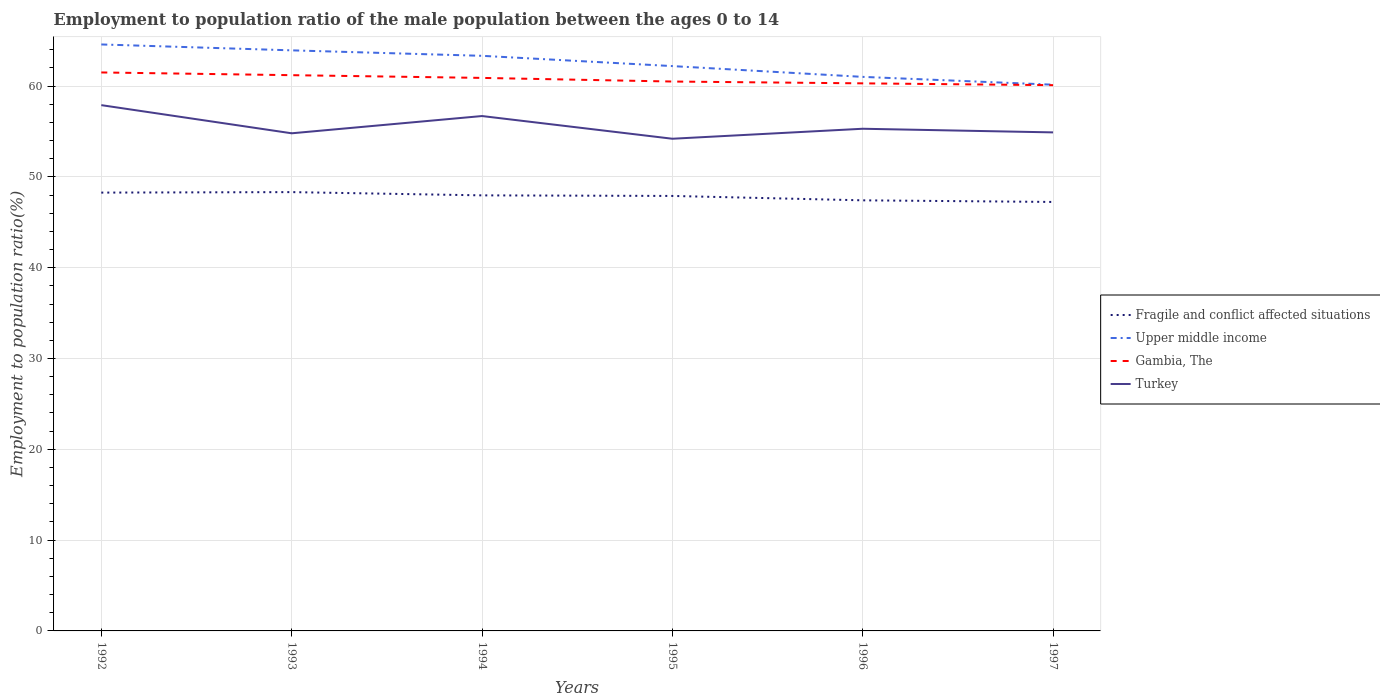How many different coloured lines are there?
Offer a terse response. 4. Does the line corresponding to Turkey intersect with the line corresponding to Fragile and conflict affected situations?
Your answer should be very brief. No. Is the number of lines equal to the number of legend labels?
Make the answer very short. Yes. Across all years, what is the maximum employment to population ratio in Fragile and conflict affected situations?
Offer a very short reply. 47.24. In which year was the employment to population ratio in Gambia, The maximum?
Provide a short and direct response. 1997. What is the total employment to population ratio in Fragile and conflict affected situations in the graph?
Provide a succinct answer. 0.48. What is the difference between the highest and the second highest employment to population ratio in Fragile and conflict affected situations?
Keep it short and to the point. 1.08. What is the difference between the highest and the lowest employment to population ratio in Gambia, The?
Your answer should be compact. 3. How many lines are there?
Your answer should be compact. 4. How many years are there in the graph?
Make the answer very short. 6. Are the values on the major ticks of Y-axis written in scientific E-notation?
Ensure brevity in your answer.  No. Does the graph contain any zero values?
Keep it short and to the point. No. How many legend labels are there?
Provide a short and direct response. 4. What is the title of the graph?
Keep it short and to the point. Employment to population ratio of the male population between the ages 0 to 14. What is the Employment to population ratio(%) in Fragile and conflict affected situations in 1992?
Give a very brief answer. 48.27. What is the Employment to population ratio(%) of Upper middle income in 1992?
Give a very brief answer. 64.58. What is the Employment to population ratio(%) of Gambia, The in 1992?
Provide a succinct answer. 61.5. What is the Employment to population ratio(%) in Turkey in 1992?
Give a very brief answer. 57.9. What is the Employment to population ratio(%) of Fragile and conflict affected situations in 1993?
Give a very brief answer. 48.32. What is the Employment to population ratio(%) in Upper middle income in 1993?
Your response must be concise. 63.93. What is the Employment to population ratio(%) of Gambia, The in 1993?
Provide a succinct answer. 61.2. What is the Employment to population ratio(%) of Turkey in 1993?
Your response must be concise. 54.8. What is the Employment to population ratio(%) in Fragile and conflict affected situations in 1994?
Offer a very short reply. 47.96. What is the Employment to population ratio(%) of Upper middle income in 1994?
Offer a terse response. 63.33. What is the Employment to population ratio(%) of Gambia, The in 1994?
Your answer should be very brief. 60.9. What is the Employment to population ratio(%) in Turkey in 1994?
Make the answer very short. 56.7. What is the Employment to population ratio(%) of Fragile and conflict affected situations in 1995?
Provide a short and direct response. 47.9. What is the Employment to population ratio(%) in Upper middle income in 1995?
Make the answer very short. 62.2. What is the Employment to population ratio(%) in Gambia, The in 1995?
Provide a succinct answer. 60.5. What is the Employment to population ratio(%) in Turkey in 1995?
Make the answer very short. 54.2. What is the Employment to population ratio(%) in Fragile and conflict affected situations in 1996?
Your answer should be very brief. 47.42. What is the Employment to population ratio(%) in Upper middle income in 1996?
Provide a succinct answer. 61.01. What is the Employment to population ratio(%) of Gambia, The in 1996?
Offer a terse response. 60.3. What is the Employment to population ratio(%) of Turkey in 1996?
Offer a terse response. 55.3. What is the Employment to population ratio(%) of Fragile and conflict affected situations in 1997?
Your answer should be compact. 47.24. What is the Employment to population ratio(%) in Upper middle income in 1997?
Your response must be concise. 60.15. What is the Employment to population ratio(%) in Gambia, The in 1997?
Provide a short and direct response. 60.1. What is the Employment to population ratio(%) in Turkey in 1997?
Provide a succinct answer. 54.9. Across all years, what is the maximum Employment to population ratio(%) in Fragile and conflict affected situations?
Keep it short and to the point. 48.32. Across all years, what is the maximum Employment to population ratio(%) in Upper middle income?
Offer a very short reply. 64.58. Across all years, what is the maximum Employment to population ratio(%) of Gambia, The?
Provide a short and direct response. 61.5. Across all years, what is the maximum Employment to population ratio(%) in Turkey?
Offer a terse response. 57.9. Across all years, what is the minimum Employment to population ratio(%) in Fragile and conflict affected situations?
Make the answer very short. 47.24. Across all years, what is the minimum Employment to population ratio(%) of Upper middle income?
Provide a short and direct response. 60.15. Across all years, what is the minimum Employment to population ratio(%) in Gambia, The?
Make the answer very short. 60.1. Across all years, what is the minimum Employment to population ratio(%) of Turkey?
Provide a succinct answer. 54.2. What is the total Employment to population ratio(%) of Fragile and conflict affected situations in the graph?
Make the answer very short. 287.12. What is the total Employment to population ratio(%) of Upper middle income in the graph?
Provide a succinct answer. 375.22. What is the total Employment to population ratio(%) of Gambia, The in the graph?
Keep it short and to the point. 364.5. What is the total Employment to population ratio(%) in Turkey in the graph?
Provide a short and direct response. 333.8. What is the difference between the Employment to population ratio(%) of Fragile and conflict affected situations in 1992 and that in 1993?
Provide a short and direct response. -0.05. What is the difference between the Employment to population ratio(%) in Upper middle income in 1992 and that in 1993?
Ensure brevity in your answer.  0.65. What is the difference between the Employment to population ratio(%) of Fragile and conflict affected situations in 1992 and that in 1994?
Your answer should be compact. 0.3. What is the difference between the Employment to population ratio(%) of Upper middle income in 1992 and that in 1994?
Your answer should be compact. 1.25. What is the difference between the Employment to population ratio(%) of Fragile and conflict affected situations in 1992 and that in 1995?
Your answer should be very brief. 0.37. What is the difference between the Employment to population ratio(%) of Upper middle income in 1992 and that in 1995?
Offer a terse response. 2.38. What is the difference between the Employment to population ratio(%) in Gambia, The in 1992 and that in 1995?
Make the answer very short. 1. What is the difference between the Employment to population ratio(%) of Fragile and conflict affected situations in 1992 and that in 1996?
Your answer should be very brief. 0.85. What is the difference between the Employment to population ratio(%) in Upper middle income in 1992 and that in 1996?
Your answer should be very brief. 3.57. What is the difference between the Employment to population ratio(%) in Gambia, The in 1992 and that in 1996?
Ensure brevity in your answer.  1.2. What is the difference between the Employment to population ratio(%) of Fragile and conflict affected situations in 1992 and that in 1997?
Ensure brevity in your answer.  1.03. What is the difference between the Employment to population ratio(%) in Upper middle income in 1992 and that in 1997?
Provide a succinct answer. 4.43. What is the difference between the Employment to population ratio(%) in Fragile and conflict affected situations in 1993 and that in 1994?
Keep it short and to the point. 0.36. What is the difference between the Employment to population ratio(%) in Upper middle income in 1993 and that in 1994?
Ensure brevity in your answer.  0.6. What is the difference between the Employment to population ratio(%) of Fragile and conflict affected situations in 1993 and that in 1995?
Keep it short and to the point. 0.42. What is the difference between the Employment to population ratio(%) of Upper middle income in 1993 and that in 1995?
Ensure brevity in your answer.  1.73. What is the difference between the Employment to population ratio(%) in Gambia, The in 1993 and that in 1995?
Provide a succinct answer. 0.7. What is the difference between the Employment to population ratio(%) in Fragile and conflict affected situations in 1993 and that in 1996?
Offer a terse response. 0.9. What is the difference between the Employment to population ratio(%) of Upper middle income in 1993 and that in 1996?
Offer a very short reply. 2.92. What is the difference between the Employment to population ratio(%) in Gambia, The in 1993 and that in 1996?
Provide a short and direct response. 0.9. What is the difference between the Employment to population ratio(%) of Fragile and conflict affected situations in 1993 and that in 1997?
Keep it short and to the point. 1.08. What is the difference between the Employment to population ratio(%) of Upper middle income in 1993 and that in 1997?
Offer a terse response. 3.78. What is the difference between the Employment to population ratio(%) of Gambia, The in 1993 and that in 1997?
Your answer should be compact. 1.1. What is the difference between the Employment to population ratio(%) of Fragile and conflict affected situations in 1994 and that in 1995?
Give a very brief answer. 0.06. What is the difference between the Employment to population ratio(%) of Upper middle income in 1994 and that in 1995?
Your answer should be very brief. 1.13. What is the difference between the Employment to population ratio(%) in Turkey in 1994 and that in 1995?
Offer a very short reply. 2.5. What is the difference between the Employment to population ratio(%) of Fragile and conflict affected situations in 1994 and that in 1996?
Your answer should be very brief. 0.55. What is the difference between the Employment to population ratio(%) of Upper middle income in 1994 and that in 1996?
Your answer should be very brief. 2.32. What is the difference between the Employment to population ratio(%) in Gambia, The in 1994 and that in 1996?
Make the answer very short. 0.6. What is the difference between the Employment to population ratio(%) in Turkey in 1994 and that in 1996?
Your answer should be very brief. 1.4. What is the difference between the Employment to population ratio(%) of Fragile and conflict affected situations in 1994 and that in 1997?
Your answer should be compact. 0.73. What is the difference between the Employment to population ratio(%) in Upper middle income in 1994 and that in 1997?
Make the answer very short. 3.18. What is the difference between the Employment to population ratio(%) of Gambia, The in 1994 and that in 1997?
Provide a succinct answer. 0.8. What is the difference between the Employment to population ratio(%) in Fragile and conflict affected situations in 1995 and that in 1996?
Provide a short and direct response. 0.48. What is the difference between the Employment to population ratio(%) of Upper middle income in 1995 and that in 1996?
Provide a succinct answer. 1.19. What is the difference between the Employment to population ratio(%) of Gambia, The in 1995 and that in 1996?
Offer a terse response. 0.2. What is the difference between the Employment to population ratio(%) in Fragile and conflict affected situations in 1995 and that in 1997?
Your answer should be very brief. 0.66. What is the difference between the Employment to population ratio(%) in Upper middle income in 1995 and that in 1997?
Keep it short and to the point. 2.05. What is the difference between the Employment to population ratio(%) in Gambia, The in 1995 and that in 1997?
Your answer should be compact. 0.4. What is the difference between the Employment to population ratio(%) in Fragile and conflict affected situations in 1996 and that in 1997?
Your answer should be very brief. 0.18. What is the difference between the Employment to population ratio(%) in Upper middle income in 1996 and that in 1997?
Provide a short and direct response. 0.86. What is the difference between the Employment to population ratio(%) in Gambia, The in 1996 and that in 1997?
Ensure brevity in your answer.  0.2. What is the difference between the Employment to population ratio(%) of Turkey in 1996 and that in 1997?
Make the answer very short. 0.4. What is the difference between the Employment to population ratio(%) of Fragile and conflict affected situations in 1992 and the Employment to population ratio(%) of Upper middle income in 1993?
Ensure brevity in your answer.  -15.66. What is the difference between the Employment to population ratio(%) in Fragile and conflict affected situations in 1992 and the Employment to population ratio(%) in Gambia, The in 1993?
Your answer should be very brief. -12.93. What is the difference between the Employment to population ratio(%) in Fragile and conflict affected situations in 1992 and the Employment to population ratio(%) in Turkey in 1993?
Provide a short and direct response. -6.53. What is the difference between the Employment to population ratio(%) of Upper middle income in 1992 and the Employment to population ratio(%) of Gambia, The in 1993?
Keep it short and to the point. 3.38. What is the difference between the Employment to population ratio(%) in Upper middle income in 1992 and the Employment to population ratio(%) in Turkey in 1993?
Provide a short and direct response. 9.78. What is the difference between the Employment to population ratio(%) in Fragile and conflict affected situations in 1992 and the Employment to population ratio(%) in Upper middle income in 1994?
Offer a very short reply. -15.06. What is the difference between the Employment to population ratio(%) of Fragile and conflict affected situations in 1992 and the Employment to population ratio(%) of Gambia, The in 1994?
Ensure brevity in your answer.  -12.63. What is the difference between the Employment to population ratio(%) in Fragile and conflict affected situations in 1992 and the Employment to population ratio(%) in Turkey in 1994?
Ensure brevity in your answer.  -8.43. What is the difference between the Employment to population ratio(%) in Upper middle income in 1992 and the Employment to population ratio(%) in Gambia, The in 1994?
Offer a terse response. 3.68. What is the difference between the Employment to population ratio(%) of Upper middle income in 1992 and the Employment to population ratio(%) of Turkey in 1994?
Make the answer very short. 7.88. What is the difference between the Employment to population ratio(%) of Gambia, The in 1992 and the Employment to population ratio(%) of Turkey in 1994?
Your answer should be very brief. 4.8. What is the difference between the Employment to population ratio(%) of Fragile and conflict affected situations in 1992 and the Employment to population ratio(%) of Upper middle income in 1995?
Ensure brevity in your answer.  -13.93. What is the difference between the Employment to population ratio(%) in Fragile and conflict affected situations in 1992 and the Employment to population ratio(%) in Gambia, The in 1995?
Your response must be concise. -12.23. What is the difference between the Employment to population ratio(%) in Fragile and conflict affected situations in 1992 and the Employment to population ratio(%) in Turkey in 1995?
Ensure brevity in your answer.  -5.93. What is the difference between the Employment to population ratio(%) of Upper middle income in 1992 and the Employment to population ratio(%) of Gambia, The in 1995?
Offer a very short reply. 4.08. What is the difference between the Employment to population ratio(%) of Upper middle income in 1992 and the Employment to population ratio(%) of Turkey in 1995?
Offer a terse response. 10.38. What is the difference between the Employment to population ratio(%) of Gambia, The in 1992 and the Employment to population ratio(%) of Turkey in 1995?
Provide a short and direct response. 7.3. What is the difference between the Employment to population ratio(%) of Fragile and conflict affected situations in 1992 and the Employment to population ratio(%) of Upper middle income in 1996?
Keep it short and to the point. -12.74. What is the difference between the Employment to population ratio(%) in Fragile and conflict affected situations in 1992 and the Employment to population ratio(%) in Gambia, The in 1996?
Offer a terse response. -12.03. What is the difference between the Employment to population ratio(%) of Fragile and conflict affected situations in 1992 and the Employment to population ratio(%) of Turkey in 1996?
Give a very brief answer. -7.03. What is the difference between the Employment to population ratio(%) in Upper middle income in 1992 and the Employment to population ratio(%) in Gambia, The in 1996?
Give a very brief answer. 4.28. What is the difference between the Employment to population ratio(%) in Upper middle income in 1992 and the Employment to population ratio(%) in Turkey in 1996?
Make the answer very short. 9.28. What is the difference between the Employment to population ratio(%) in Gambia, The in 1992 and the Employment to population ratio(%) in Turkey in 1996?
Offer a terse response. 6.2. What is the difference between the Employment to population ratio(%) in Fragile and conflict affected situations in 1992 and the Employment to population ratio(%) in Upper middle income in 1997?
Offer a very short reply. -11.88. What is the difference between the Employment to population ratio(%) of Fragile and conflict affected situations in 1992 and the Employment to population ratio(%) of Gambia, The in 1997?
Make the answer very short. -11.83. What is the difference between the Employment to population ratio(%) in Fragile and conflict affected situations in 1992 and the Employment to population ratio(%) in Turkey in 1997?
Give a very brief answer. -6.63. What is the difference between the Employment to population ratio(%) in Upper middle income in 1992 and the Employment to population ratio(%) in Gambia, The in 1997?
Give a very brief answer. 4.48. What is the difference between the Employment to population ratio(%) of Upper middle income in 1992 and the Employment to population ratio(%) of Turkey in 1997?
Provide a succinct answer. 9.68. What is the difference between the Employment to population ratio(%) in Gambia, The in 1992 and the Employment to population ratio(%) in Turkey in 1997?
Offer a very short reply. 6.6. What is the difference between the Employment to population ratio(%) of Fragile and conflict affected situations in 1993 and the Employment to population ratio(%) of Upper middle income in 1994?
Keep it short and to the point. -15.01. What is the difference between the Employment to population ratio(%) of Fragile and conflict affected situations in 1993 and the Employment to population ratio(%) of Gambia, The in 1994?
Your answer should be compact. -12.58. What is the difference between the Employment to population ratio(%) of Fragile and conflict affected situations in 1993 and the Employment to population ratio(%) of Turkey in 1994?
Offer a terse response. -8.38. What is the difference between the Employment to population ratio(%) in Upper middle income in 1993 and the Employment to population ratio(%) in Gambia, The in 1994?
Offer a very short reply. 3.03. What is the difference between the Employment to population ratio(%) of Upper middle income in 1993 and the Employment to population ratio(%) of Turkey in 1994?
Offer a terse response. 7.23. What is the difference between the Employment to population ratio(%) in Fragile and conflict affected situations in 1993 and the Employment to population ratio(%) in Upper middle income in 1995?
Provide a succinct answer. -13.88. What is the difference between the Employment to population ratio(%) in Fragile and conflict affected situations in 1993 and the Employment to population ratio(%) in Gambia, The in 1995?
Your answer should be compact. -12.18. What is the difference between the Employment to population ratio(%) of Fragile and conflict affected situations in 1993 and the Employment to population ratio(%) of Turkey in 1995?
Provide a short and direct response. -5.88. What is the difference between the Employment to population ratio(%) of Upper middle income in 1993 and the Employment to population ratio(%) of Gambia, The in 1995?
Ensure brevity in your answer.  3.43. What is the difference between the Employment to population ratio(%) of Upper middle income in 1993 and the Employment to population ratio(%) of Turkey in 1995?
Keep it short and to the point. 9.73. What is the difference between the Employment to population ratio(%) of Gambia, The in 1993 and the Employment to population ratio(%) of Turkey in 1995?
Make the answer very short. 7. What is the difference between the Employment to population ratio(%) of Fragile and conflict affected situations in 1993 and the Employment to population ratio(%) of Upper middle income in 1996?
Your response must be concise. -12.69. What is the difference between the Employment to population ratio(%) of Fragile and conflict affected situations in 1993 and the Employment to population ratio(%) of Gambia, The in 1996?
Ensure brevity in your answer.  -11.98. What is the difference between the Employment to population ratio(%) of Fragile and conflict affected situations in 1993 and the Employment to population ratio(%) of Turkey in 1996?
Make the answer very short. -6.98. What is the difference between the Employment to population ratio(%) of Upper middle income in 1993 and the Employment to population ratio(%) of Gambia, The in 1996?
Make the answer very short. 3.63. What is the difference between the Employment to population ratio(%) in Upper middle income in 1993 and the Employment to population ratio(%) in Turkey in 1996?
Your answer should be very brief. 8.63. What is the difference between the Employment to population ratio(%) of Fragile and conflict affected situations in 1993 and the Employment to population ratio(%) of Upper middle income in 1997?
Make the answer very short. -11.83. What is the difference between the Employment to population ratio(%) of Fragile and conflict affected situations in 1993 and the Employment to population ratio(%) of Gambia, The in 1997?
Make the answer very short. -11.78. What is the difference between the Employment to population ratio(%) in Fragile and conflict affected situations in 1993 and the Employment to population ratio(%) in Turkey in 1997?
Keep it short and to the point. -6.58. What is the difference between the Employment to population ratio(%) in Upper middle income in 1993 and the Employment to population ratio(%) in Gambia, The in 1997?
Keep it short and to the point. 3.83. What is the difference between the Employment to population ratio(%) in Upper middle income in 1993 and the Employment to population ratio(%) in Turkey in 1997?
Make the answer very short. 9.03. What is the difference between the Employment to population ratio(%) of Fragile and conflict affected situations in 1994 and the Employment to population ratio(%) of Upper middle income in 1995?
Offer a terse response. -14.24. What is the difference between the Employment to population ratio(%) in Fragile and conflict affected situations in 1994 and the Employment to population ratio(%) in Gambia, The in 1995?
Keep it short and to the point. -12.54. What is the difference between the Employment to population ratio(%) of Fragile and conflict affected situations in 1994 and the Employment to population ratio(%) of Turkey in 1995?
Make the answer very short. -6.24. What is the difference between the Employment to population ratio(%) in Upper middle income in 1994 and the Employment to population ratio(%) in Gambia, The in 1995?
Your answer should be compact. 2.83. What is the difference between the Employment to population ratio(%) of Upper middle income in 1994 and the Employment to population ratio(%) of Turkey in 1995?
Your response must be concise. 9.13. What is the difference between the Employment to population ratio(%) of Gambia, The in 1994 and the Employment to population ratio(%) of Turkey in 1995?
Give a very brief answer. 6.7. What is the difference between the Employment to population ratio(%) of Fragile and conflict affected situations in 1994 and the Employment to population ratio(%) of Upper middle income in 1996?
Ensure brevity in your answer.  -13.05. What is the difference between the Employment to population ratio(%) in Fragile and conflict affected situations in 1994 and the Employment to population ratio(%) in Gambia, The in 1996?
Offer a very short reply. -12.34. What is the difference between the Employment to population ratio(%) of Fragile and conflict affected situations in 1994 and the Employment to population ratio(%) of Turkey in 1996?
Provide a short and direct response. -7.33. What is the difference between the Employment to population ratio(%) in Upper middle income in 1994 and the Employment to population ratio(%) in Gambia, The in 1996?
Provide a succinct answer. 3.03. What is the difference between the Employment to population ratio(%) in Upper middle income in 1994 and the Employment to population ratio(%) in Turkey in 1996?
Offer a terse response. 8.03. What is the difference between the Employment to population ratio(%) in Fragile and conflict affected situations in 1994 and the Employment to population ratio(%) in Upper middle income in 1997?
Keep it short and to the point. -12.19. What is the difference between the Employment to population ratio(%) of Fragile and conflict affected situations in 1994 and the Employment to population ratio(%) of Gambia, The in 1997?
Provide a succinct answer. -12.13. What is the difference between the Employment to population ratio(%) in Fragile and conflict affected situations in 1994 and the Employment to population ratio(%) in Turkey in 1997?
Your response must be concise. -6.94. What is the difference between the Employment to population ratio(%) of Upper middle income in 1994 and the Employment to population ratio(%) of Gambia, The in 1997?
Ensure brevity in your answer.  3.23. What is the difference between the Employment to population ratio(%) in Upper middle income in 1994 and the Employment to population ratio(%) in Turkey in 1997?
Keep it short and to the point. 8.43. What is the difference between the Employment to population ratio(%) of Gambia, The in 1994 and the Employment to population ratio(%) of Turkey in 1997?
Offer a terse response. 6. What is the difference between the Employment to population ratio(%) in Fragile and conflict affected situations in 1995 and the Employment to population ratio(%) in Upper middle income in 1996?
Offer a very short reply. -13.11. What is the difference between the Employment to population ratio(%) of Fragile and conflict affected situations in 1995 and the Employment to population ratio(%) of Gambia, The in 1996?
Your response must be concise. -12.4. What is the difference between the Employment to population ratio(%) of Fragile and conflict affected situations in 1995 and the Employment to population ratio(%) of Turkey in 1996?
Your answer should be compact. -7.4. What is the difference between the Employment to population ratio(%) in Upper middle income in 1995 and the Employment to population ratio(%) in Gambia, The in 1996?
Your answer should be compact. 1.9. What is the difference between the Employment to population ratio(%) in Upper middle income in 1995 and the Employment to population ratio(%) in Turkey in 1996?
Ensure brevity in your answer.  6.9. What is the difference between the Employment to population ratio(%) in Gambia, The in 1995 and the Employment to population ratio(%) in Turkey in 1996?
Offer a very short reply. 5.2. What is the difference between the Employment to population ratio(%) in Fragile and conflict affected situations in 1995 and the Employment to population ratio(%) in Upper middle income in 1997?
Make the answer very short. -12.25. What is the difference between the Employment to population ratio(%) in Fragile and conflict affected situations in 1995 and the Employment to population ratio(%) in Gambia, The in 1997?
Make the answer very short. -12.2. What is the difference between the Employment to population ratio(%) in Fragile and conflict affected situations in 1995 and the Employment to population ratio(%) in Turkey in 1997?
Offer a very short reply. -7. What is the difference between the Employment to population ratio(%) in Upper middle income in 1995 and the Employment to population ratio(%) in Gambia, The in 1997?
Give a very brief answer. 2.1. What is the difference between the Employment to population ratio(%) of Upper middle income in 1995 and the Employment to population ratio(%) of Turkey in 1997?
Ensure brevity in your answer.  7.3. What is the difference between the Employment to population ratio(%) of Fragile and conflict affected situations in 1996 and the Employment to population ratio(%) of Upper middle income in 1997?
Provide a short and direct response. -12.73. What is the difference between the Employment to population ratio(%) of Fragile and conflict affected situations in 1996 and the Employment to population ratio(%) of Gambia, The in 1997?
Ensure brevity in your answer.  -12.68. What is the difference between the Employment to population ratio(%) in Fragile and conflict affected situations in 1996 and the Employment to population ratio(%) in Turkey in 1997?
Make the answer very short. -7.48. What is the difference between the Employment to population ratio(%) in Upper middle income in 1996 and the Employment to population ratio(%) in Gambia, The in 1997?
Offer a terse response. 0.91. What is the difference between the Employment to population ratio(%) in Upper middle income in 1996 and the Employment to population ratio(%) in Turkey in 1997?
Provide a short and direct response. 6.11. What is the difference between the Employment to population ratio(%) in Gambia, The in 1996 and the Employment to population ratio(%) in Turkey in 1997?
Keep it short and to the point. 5.4. What is the average Employment to population ratio(%) in Fragile and conflict affected situations per year?
Provide a short and direct response. 47.85. What is the average Employment to population ratio(%) of Upper middle income per year?
Offer a very short reply. 62.54. What is the average Employment to population ratio(%) in Gambia, The per year?
Your answer should be compact. 60.75. What is the average Employment to population ratio(%) in Turkey per year?
Your answer should be very brief. 55.63. In the year 1992, what is the difference between the Employment to population ratio(%) of Fragile and conflict affected situations and Employment to population ratio(%) of Upper middle income?
Ensure brevity in your answer.  -16.31. In the year 1992, what is the difference between the Employment to population ratio(%) in Fragile and conflict affected situations and Employment to population ratio(%) in Gambia, The?
Provide a succinct answer. -13.23. In the year 1992, what is the difference between the Employment to population ratio(%) of Fragile and conflict affected situations and Employment to population ratio(%) of Turkey?
Make the answer very short. -9.63. In the year 1992, what is the difference between the Employment to population ratio(%) in Upper middle income and Employment to population ratio(%) in Gambia, The?
Your response must be concise. 3.08. In the year 1992, what is the difference between the Employment to population ratio(%) in Upper middle income and Employment to population ratio(%) in Turkey?
Provide a succinct answer. 6.68. In the year 1993, what is the difference between the Employment to population ratio(%) in Fragile and conflict affected situations and Employment to population ratio(%) in Upper middle income?
Give a very brief answer. -15.61. In the year 1993, what is the difference between the Employment to population ratio(%) of Fragile and conflict affected situations and Employment to population ratio(%) of Gambia, The?
Give a very brief answer. -12.88. In the year 1993, what is the difference between the Employment to population ratio(%) in Fragile and conflict affected situations and Employment to population ratio(%) in Turkey?
Offer a terse response. -6.48. In the year 1993, what is the difference between the Employment to population ratio(%) in Upper middle income and Employment to population ratio(%) in Gambia, The?
Ensure brevity in your answer.  2.73. In the year 1993, what is the difference between the Employment to population ratio(%) in Upper middle income and Employment to population ratio(%) in Turkey?
Provide a succinct answer. 9.13. In the year 1994, what is the difference between the Employment to population ratio(%) of Fragile and conflict affected situations and Employment to population ratio(%) of Upper middle income?
Offer a very short reply. -15.37. In the year 1994, what is the difference between the Employment to population ratio(%) in Fragile and conflict affected situations and Employment to population ratio(%) in Gambia, The?
Ensure brevity in your answer.  -12.94. In the year 1994, what is the difference between the Employment to population ratio(%) in Fragile and conflict affected situations and Employment to population ratio(%) in Turkey?
Ensure brevity in your answer.  -8.74. In the year 1994, what is the difference between the Employment to population ratio(%) in Upper middle income and Employment to population ratio(%) in Gambia, The?
Ensure brevity in your answer.  2.43. In the year 1994, what is the difference between the Employment to population ratio(%) of Upper middle income and Employment to population ratio(%) of Turkey?
Give a very brief answer. 6.63. In the year 1994, what is the difference between the Employment to population ratio(%) in Gambia, The and Employment to population ratio(%) in Turkey?
Give a very brief answer. 4.2. In the year 1995, what is the difference between the Employment to population ratio(%) in Fragile and conflict affected situations and Employment to population ratio(%) in Upper middle income?
Your answer should be compact. -14.3. In the year 1995, what is the difference between the Employment to population ratio(%) in Fragile and conflict affected situations and Employment to population ratio(%) in Gambia, The?
Your response must be concise. -12.6. In the year 1995, what is the difference between the Employment to population ratio(%) in Fragile and conflict affected situations and Employment to population ratio(%) in Turkey?
Ensure brevity in your answer.  -6.3. In the year 1995, what is the difference between the Employment to population ratio(%) of Upper middle income and Employment to population ratio(%) of Gambia, The?
Provide a short and direct response. 1.7. In the year 1995, what is the difference between the Employment to population ratio(%) in Upper middle income and Employment to population ratio(%) in Turkey?
Offer a terse response. 8. In the year 1995, what is the difference between the Employment to population ratio(%) of Gambia, The and Employment to population ratio(%) of Turkey?
Your answer should be compact. 6.3. In the year 1996, what is the difference between the Employment to population ratio(%) of Fragile and conflict affected situations and Employment to population ratio(%) of Upper middle income?
Keep it short and to the point. -13.6. In the year 1996, what is the difference between the Employment to population ratio(%) in Fragile and conflict affected situations and Employment to population ratio(%) in Gambia, The?
Your response must be concise. -12.88. In the year 1996, what is the difference between the Employment to population ratio(%) of Fragile and conflict affected situations and Employment to population ratio(%) of Turkey?
Provide a short and direct response. -7.88. In the year 1996, what is the difference between the Employment to population ratio(%) of Upper middle income and Employment to population ratio(%) of Gambia, The?
Your answer should be compact. 0.71. In the year 1996, what is the difference between the Employment to population ratio(%) of Upper middle income and Employment to population ratio(%) of Turkey?
Keep it short and to the point. 5.71. In the year 1997, what is the difference between the Employment to population ratio(%) in Fragile and conflict affected situations and Employment to population ratio(%) in Upper middle income?
Offer a terse response. -12.91. In the year 1997, what is the difference between the Employment to population ratio(%) of Fragile and conflict affected situations and Employment to population ratio(%) of Gambia, The?
Provide a short and direct response. -12.86. In the year 1997, what is the difference between the Employment to population ratio(%) of Fragile and conflict affected situations and Employment to population ratio(%) of Turkey?
Keep it short and to the point. -7.66. In the year 1997, what is the difference between the Employment to population ratio(%) in Upper middle income and Employment to population ratio(%) in Gambia, The?
Keep it short and to the point. 0.05. In the year 1997, what is the difference between the Employment to population ratio(%) of Upper middle income and Employment to population ratio(%) of Turkey?
Ensure brevity in your answer.  5.25. In the year 1997, what is the difference between the Employment to population ratio(%) in Gambia, The and Employment to population ratio(%) in Turkey?
Offer a very short reply. 5.2. What is the ratio of the Employment to population ratio(%) of Fragile and conflict affected situations in 1992 to that in 1993?
Provide a short and direct response. 1. What is the ratio of the Employment to population ratio(%) in Upper middle income in 1992 to that in 1993?
Your answer should be compact. 1.01. What is the ratio of the Employment to population ratio(%) of Gambia, The in 1992 to that in 1993?
Make the answer very short. 1. What is the ratio of the Employment to population ratio(%) in Turkey in 1992 to that in 1993?
Give a very brief answer. 1.06. What is the ratio of the Employment to population ratio(%) of Fragile and conflict affected situations in 1992 to that in 1994?
Provide a succinct answer. 1.01. What is the ratio of the Employment to population ratio(%) of Upper middle income in 1992 to that in 1994?
Ensure brevity in your answer.  1.02. What is the ratio of the Employment to population ratio(%) of Gambia, The in 1992 to that in 1994?
Make the answer very short. 1.01. What is the ratio of the Employment to population ratio(%) in Turkey in 1992 to that in 1994?
Your response must be concise. 1.02. What is the ratio of the Employment to population ratio(%) of Fragile and conflict affected situations in 1992 to that in 1995?
Ensure brevity in your answer.  1.01. What is the ratio of the Employment to population ratio(%) in Upper middle income in 1992 to that in 1995?
Provide a short and direct response. 1.04. What is the ratio of the Employment to population ratio(%) in Gambia, The in 1992 to that in 1995?
Your answer should be very brief. 1.02. What is the ratio of the Employment to population ratio(%) in Turkey in 1992 to that in 1995?
Keep it short and to the point. 1.07. What is the ratio of the Employment to population ratio(%) of Fragile and conflict affected situations in 1992 to that in 1996?
Provide a succinct answer. 1.02. What is the ratio of the Employment to population ratio(%) of Upper middle income in 1992 to that in 1996?
Your answer should be compact. 1.06. What is the ratio of the Employment to population ratio(%) in Gambia, The in 1992 to that in 1996?
Ensure brevity in your answer.  1.02. What is the ratio of the Employment to population ratio(%) of Turkey in 1992 to that in 1996?
Offer a terse response. 1.05. What is the ratio of the Employment to population ratio(%) of Fragile and conflict affected situations in 1992 to that in 1997?
Your response must be concise. 1.02. What is the ratio of the Employment to population ratio(%) in Upper middle income in 1992 to that in 1997?
Ensure brevity in your answer.  1.07. What is the ratio of the Employment to population ratio(%) in Gambia, The in 1992 to that in 1997?
Provide a succinct answer. 1.02. What is the ratio of the Employment to population ratio(%) of Turkey in 1992 to that in 1997?
Keep it short and to the point. 1.05. What is the ratio of the Employment to population ratio(%) of Fragile and conflict affected situations in 1993 to that in 1994?
Provide a short and direct response. 1.01. What is the ratio of the Employment to population ratio(%) of Upper middle income in 1993 to that in 1994?
Your answer should be compact. 1.01. What is the ratio of the Employment to population ratio(%) in Gambia, The in 1993 to that in 1994?
Give a very brief answer. 1. What is the ratio of the Employment to population ratio(%) of Turkey in 1993 to that in 1994?
Offer a terse response. 0.97. What is the ratio of the Employment to population ratio(%) in Fragile and conflict affected situations in 1993 to that in 1995?
Keep it short and to the point. 1.01. What is the ratio of the Employment to population ratio(%) of Upper middle income in 1993 to that in 1995?
Your answer should be compact. 1.03. What is the ratio of the Employment to population ratio(%) of Gambia, The in 1993 to that in 1995?
Give a very brief answer. 1.01. What is the ratio of the Employment to population ratio(%) of Turkey in 1993 to that in 1995?
Make the answer very short. 1.01. What is the ratio of the Employment to population ratio(%) in Fragile and conflict affected situations in 1993 to that in 1996?
Make the answer very short. 1.02. What is the ratio of the Employment to population ratio(%) of Upper middle income in 1993 to that in 1996?
Offer a terse response. 1.05. What is the ratio of the Employment to population ratio(%) of Gambia, The in 1993 to that in 1996?
Keep it short and to the point. 1.01. What is the ratio of the Employment to population ratio(%) in Turkey in 1993 to that in 1996?
Give a very brief answer. 0.99. What is the ratio of the Employment to population ratio(%) of Fragile and conflict affected situations in 1993 to that in 1997?
Give a very brief answer. 1.02. What is the ratio of the Employment to population ratio(%) of Upper middle income in 1993 to that in 1997?
Offer a very short reply. 1.06. What is the ratio of the Employment to population ratio(%) of Gambia, The in 1993 to that in 1997?
Give a very brief answer. 1.02. What is the ratio of the Employment to population ratio(%) of Turkey in 1993 to that in 1997?
Give a very brief answer. 1. What is the ratio of the Employment to population ratio(%) in Upper middle income in 1994 to that in 1995?
Offer a terse response. 1.02. What is the ratio of the Employment to population ratio(%) of Gambia, The in 1994 to that in 1995?
Keep it short and to the point. 1.01. What is the ratio of the Employment to population ratio(%) of Turkey in 1994 to that in 1995?
Provide a succinct answer. 1.05. What is the ratio of the Employment to population ratio(%) in Fragile and conflict affected situations in 1994 to that in 1996?
Your answer should be very brief. 1.01. What is the ratio of the Employment to population ratio(%) of Upper middle income in 1994 to that in 1996?
Give a very brief answer. 1.04. What is the ratio of the Employment to population ratio(%) in Gambia, The in 1994 to that in 1996?
Provide a short and direct response. 1.01. What is the ratio of the Employment to population ratio(%) of Turkey in 1994 to that in 1996?
Your response must be concise. 1.03. What is the ratio of the Employment to population ratio(%) of Fragile and conflict affected situations in 1994 to that in 1997?
Ensure brevity in your answer.  1.02. What is the ratio of the Employment to population ratio(%) of Upper middle income in 1994 to that in 1997?
Provide a succinct answer. 1.05. What is the ratio of the Employment to population ratio(%) of Gambia, The in 1994 to that in 1997?
Your response must be concise. 1.01. What is the ratio of the Employment to population ratio(%) in Turkey in 1994 to that in 1997?
Your response must be concise. 1.03. What is the ratio of the Employment to population ratio(%) of Fragile and conflict affected situations in 1995 to that in 1996?
Provide a succinct answer. 1.01. What is the ratio of the Employment to population ratio(%) in Upper middle income in 1995 to that in 1996?
Your response must be concise. 1.02. What is the ratio of the Employment to population ratio(%) of Turkey in 1995 to that in 1996?
Ensure brevity in your answer.  0.98. What is the ratio of the Employment to population ratio(%) of Upper middle income in 1995 to that in 1997?
Provide a short and direct response. 1.03. What is the ratio of the Employment to population ratio(%) of Gambia, The in 1995 to that in 1997?
Your answer should be very brief. 1.01. What is the ratio of the Employment to population ratio(%) of Turkey in 1995 to that in 1997?
Make the answer very short. 0.99. What is the ratio of the Employment to population ratio(%) of Fragile and conflict affected situations in 1996 to that in 1997?
Your answer should be very brief. 1. What is the ratio of the Employment to population ratio(%) in Upper middle income in 1996 to that in 1997?
Your response must be concise. 1.01. What is the ratio of the Employment to population ratio(%) of Turkey in 1996 to that in 1997?
Make the answer very short. 1.01. What is the difference between the highest and the second highest Employment to population ratio(%) of Fragile and conflict affected situations?
Your answer should be compact. 0.05. What is the difference between the highest and the second highest Employment to population ratio(%) in Upper middle income?
Your answer should be very brief. 0.65. What is the difference between the highest and the lowest Employment to population ratio(%) of Fragile and conflict affected situations?
Offer a terse response. 1.08. What is the difference between the highest and the lowest Employment to population ratio(%) in Upper middle income?
Your answer should be compact. 4.43. 